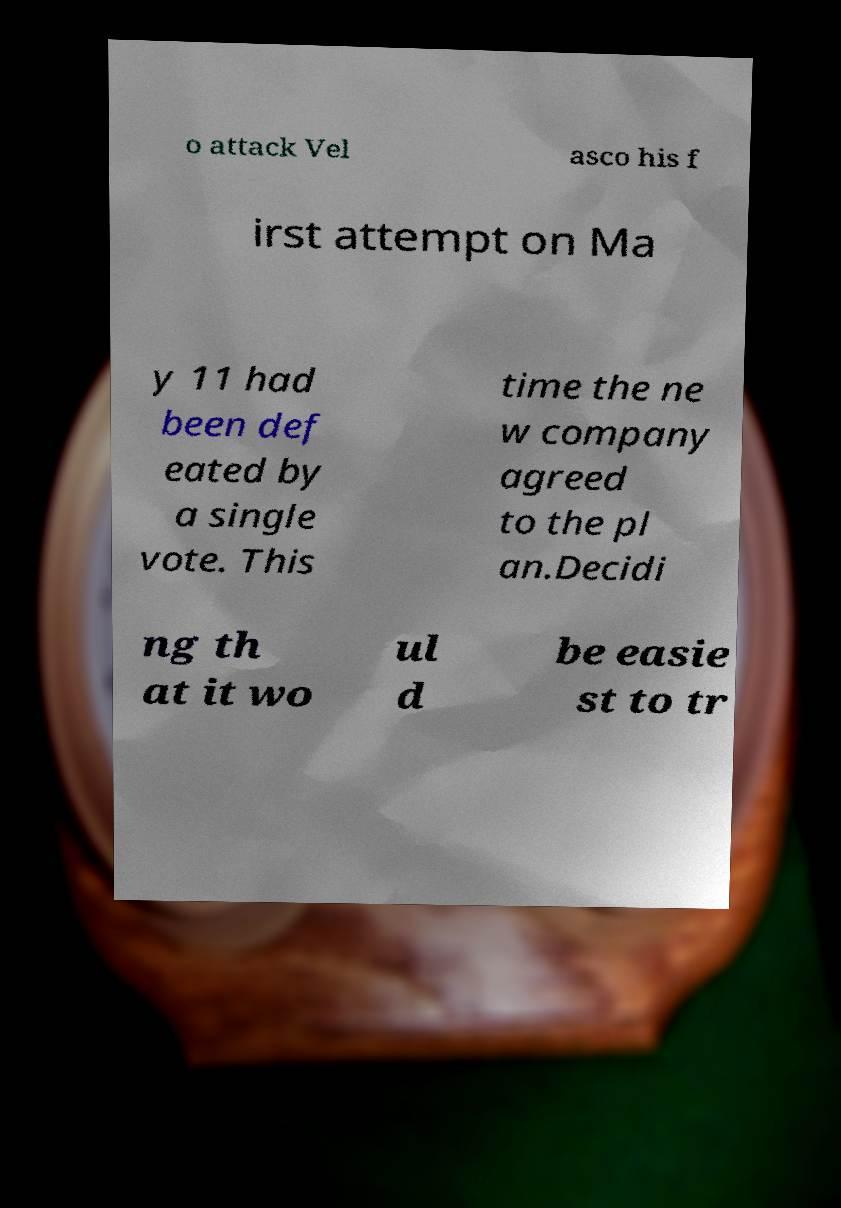What messages or text are displayed in this image? I need them in a readable, typed format. o attack Vel asco his f irst attempt on Ma y 11 had been def eated by a single vote. This time the ne w company agreed to the pl an.Decidi ng th at it wo ul d be easie st to tr 